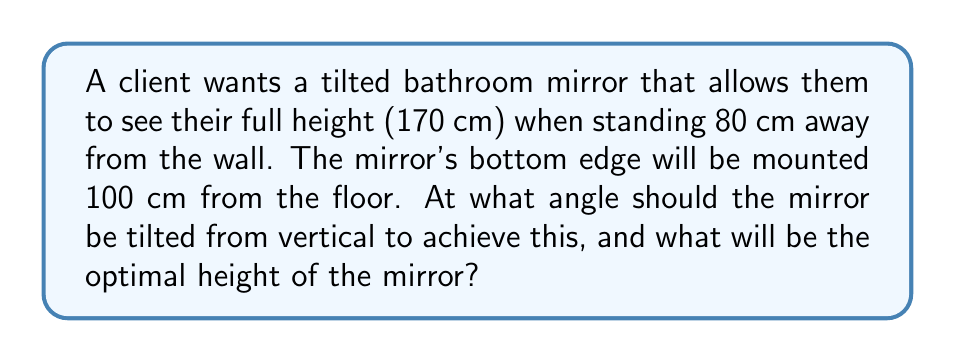Give your solution to this math problem. Let's approach this step-by-step:

1) First, let's visualize the problem:

[asy]
import geometry;

size(200);

pair A = (0,0), B = (80,0), C = (0,170), D = (0,100), E = (80,170);
draw(A--B--E--C--A);
draw(D--E,dashed);

label("Floor", (40,-5));
label("Wall", (-5,85));
label("Mirror", (35,135), E);
label("170 cm", (-5,85), W);
label("80 cm", (40,5), S);
label("100 cm", (5,50), W);
label("$\theta$", (10,105), NW);

dot("A",A,SW);
dot("B",B,SE);
dot("C",C,NW);
dot("D",D,W);
dot("E",E,NE);
[/asy]

2) We need to find the angle $\theta$ and the height of the mirror (DE).

3) In the right triangle ADE:
   $\tan(\theta) = \frac{DE}{80}$

4) In the right triangle ABC:
   $\tan(\theta) = \frac{170-100}{80} = \frac{70}{80}$

5) Therefore:
   $\theta = \arctan(\frac{70}{80}) \approx 41.19°$

6) Now that we know $\theta$, we can find DE:
   $DE = 80 \tan(\theta) = 80 \cdot \frac{70}{80} = 70$ cm

7) The total height of the mirror will be:
   $100 \text{ cm} + 70 \text{ cm} = 170$ cm

Therefore, the mirror should be tilted at approximately 41.19° from vertical, and its optimal height will be 170 cm.
Answer: $\theta \approx 41.19°$, Height $= 170$ cm 